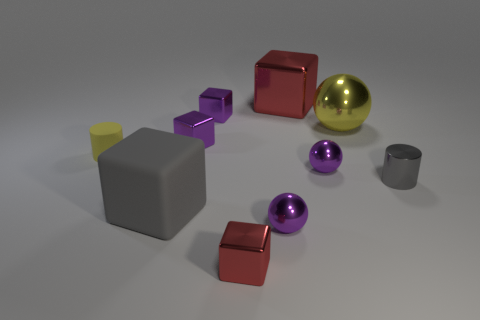Describe the arrangement of the objects. Does it suggest anything? The objects appear deliberately placed with sufficient space between them. This arrangement might suggest an intentional setup for a visual display, potentially for a study of geometry, color, or material properties under consistent lighting. 